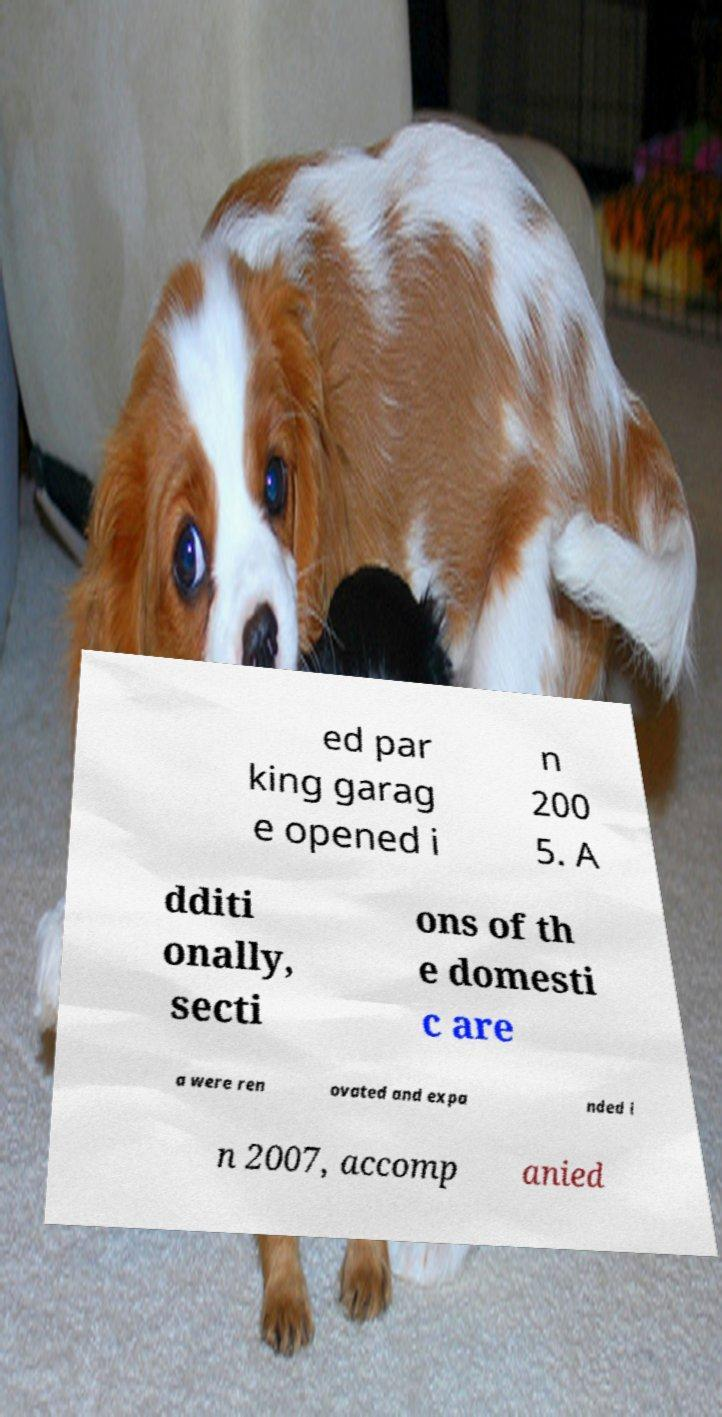Could you assist in decoding the text presented in this image and type it out clearly? ed par king garag e opened i n 200 5. A dditi onally, secti ons of th e domesti c are a were ren ovated and expa nded i n 2007, accomp anied 